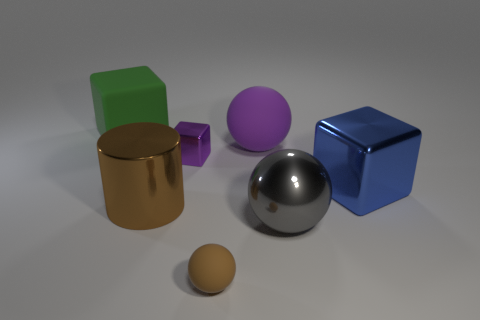Is the number of green rubber blocks in front of the green block less than the number of small red rubber spheres?
Offer a terse response. No. Is the shape of the purple matte object the same as the brown rubber object?
Your answer should be compact. Yes. There is a brown thing in front of the brown cylinder; how big is it?
Keep it short and to the point. Small. What is the size of the gray object that is made of the same material as the tiny block?
Provide a succinct answer. Large. Is the number of tiny gray shiny cylinders less than the number of large cylinders?
Your answer should be very brief. Yes. What is the material of the blue block that is the same size as the cylinder?
Make the answer very short. Metal. Are there more big brown metal spheres than rubber objects?
Give a very brief answer. No. How many other things are the same color as the big metal cube?
Give a very brief answer. 0. How many objects are both behind the tiny matte ball and in front of the purple rubber sphere?
Offer a terse response. 4. Are there more brown things that are in front of the large purple ball than brown objects on the right side of the tiny metallic object?
Offer a terse response. Yes. 